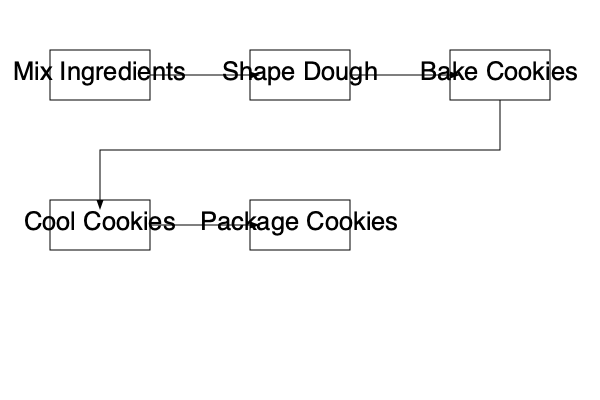Based on the flowchart, what is the correct sequence of automated steps in a cookie production line? To determine the correct sequence of automated steps in the cookie production line, we need to follow the flow of the arrows in the flowchart:

1. The process starts with "Mix Ingredients" at the top left of the flowchart.
2. An arrow leads from "Mix Ingredients" to "Shape Dough," indicating this is the second step.
3. The next arrow points from "Shape Dough" to "Bake Cookies," making this the third step.
4. After baking, a long arrow leads down and to the left to "Cool Cookies," which is the fourth step.
5. Finally, an arrow connects "Cool Cookies" to "Package Cookies," representing the last step in the process.

By following the arrows, we can determine the correct sequence of steps in the automated cookie production line.
Answer: Mix Ingredients → Shape Dough → Bake Cookies → Cool Cookies → Package Cookies 